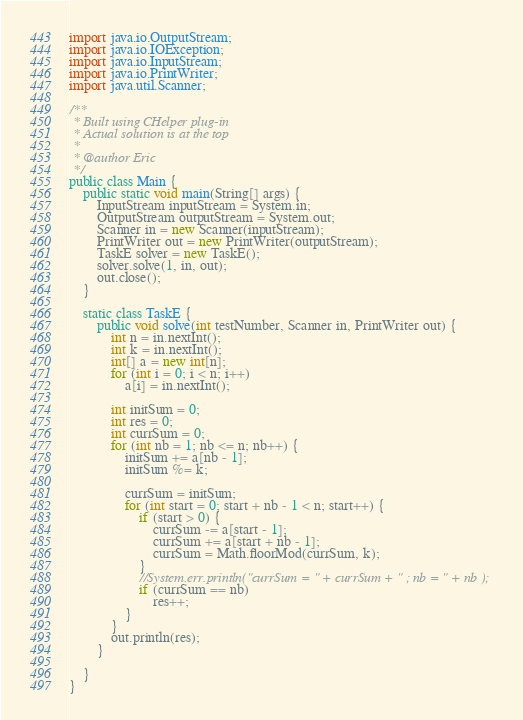<code> <loc_0><loc_0><loc_500><loc_500><_Java_>import java.io.OutputStream;
import java.io.IOException;
import java.io.InputStream;
import java.io.PrintWriter;
import java.util.Scanner;

/**
 * Built using CHelper plug-in
 * Actual solution is at the top
 *
 * @author Eric
 */
public class Main {
    public static void main(String[] args) {
        InputStream inputStream = System.in;
        OutputStream outputStream = System.out;
        Scanner in = new Scanner(inputStream);
        PrintWriter out = new PrintWriter(outputStream);
        TaskE solver = new TaskE();
        solver.solve(1, in, out);
        out.close();
    }

    static class TaskE {
        public void solve(int testNumber, Scanner in, PrintWriter out) {
            int n = in.nextInt();
            int k = in.nextInt();
            int[] a = new int[n];
            for (int i = 0; i < n; i++)
                a[i] = in.nextInt();

            int initSum = 0;
            int res = 0;
            int currSum = 0;
            for (int nb = 1; nb <= n; nb++) {
                initSum += a[nb - 1];
                initSum %= k;

                currSum = initSum;
                for (int start = 0; start + nb - 1 < n; start++) {
                    if (start > 0) {
                        currSum -= a[start - 1];
                        currSum += a[start + nb - 1];
                        currSum = Math.floorMod(currSum, k);
                    }
                    //System.err.println("currSum = " + currSum + " ; nb = " + nb );
                    if (currSum == nb)
                        res++;
                }
            }
            out.println(res);
        }

    }
}

</code> 